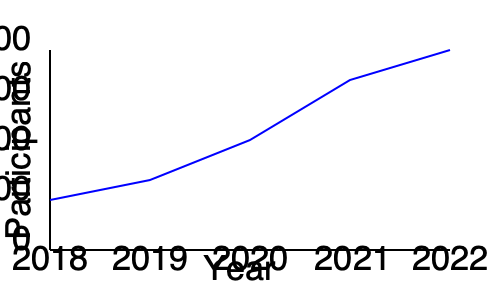Based on the line graph showing the growth of child life program participation from 2018 to 2022, what was the approximate percentage increase in participation from 2018 to 2022? To calculate the percentage increase in participation from 2018 to 2022, we need to follow these steps:

1. Identify the approximate number of participants in 2018 and 2022:
   - 2018: About 100 participants
   - 2022: About 350 participants

2. Calculate the difference in participants:
   $350 - 100 = 250$

3. Calculate the percentage increase using the formula:
   $\text{Percentage increase} = \frac{\text{Increase}}{\text{Original value}} \times 100\%$

   $\text{Percentage increase} = \frac{250}{100} \times 100\% = 2.5 \times 100\% = 250\%$

Therefore, the approximate percentage increase in child life program participation from 2018 to 2022 was 250%.
Answer: 250% 